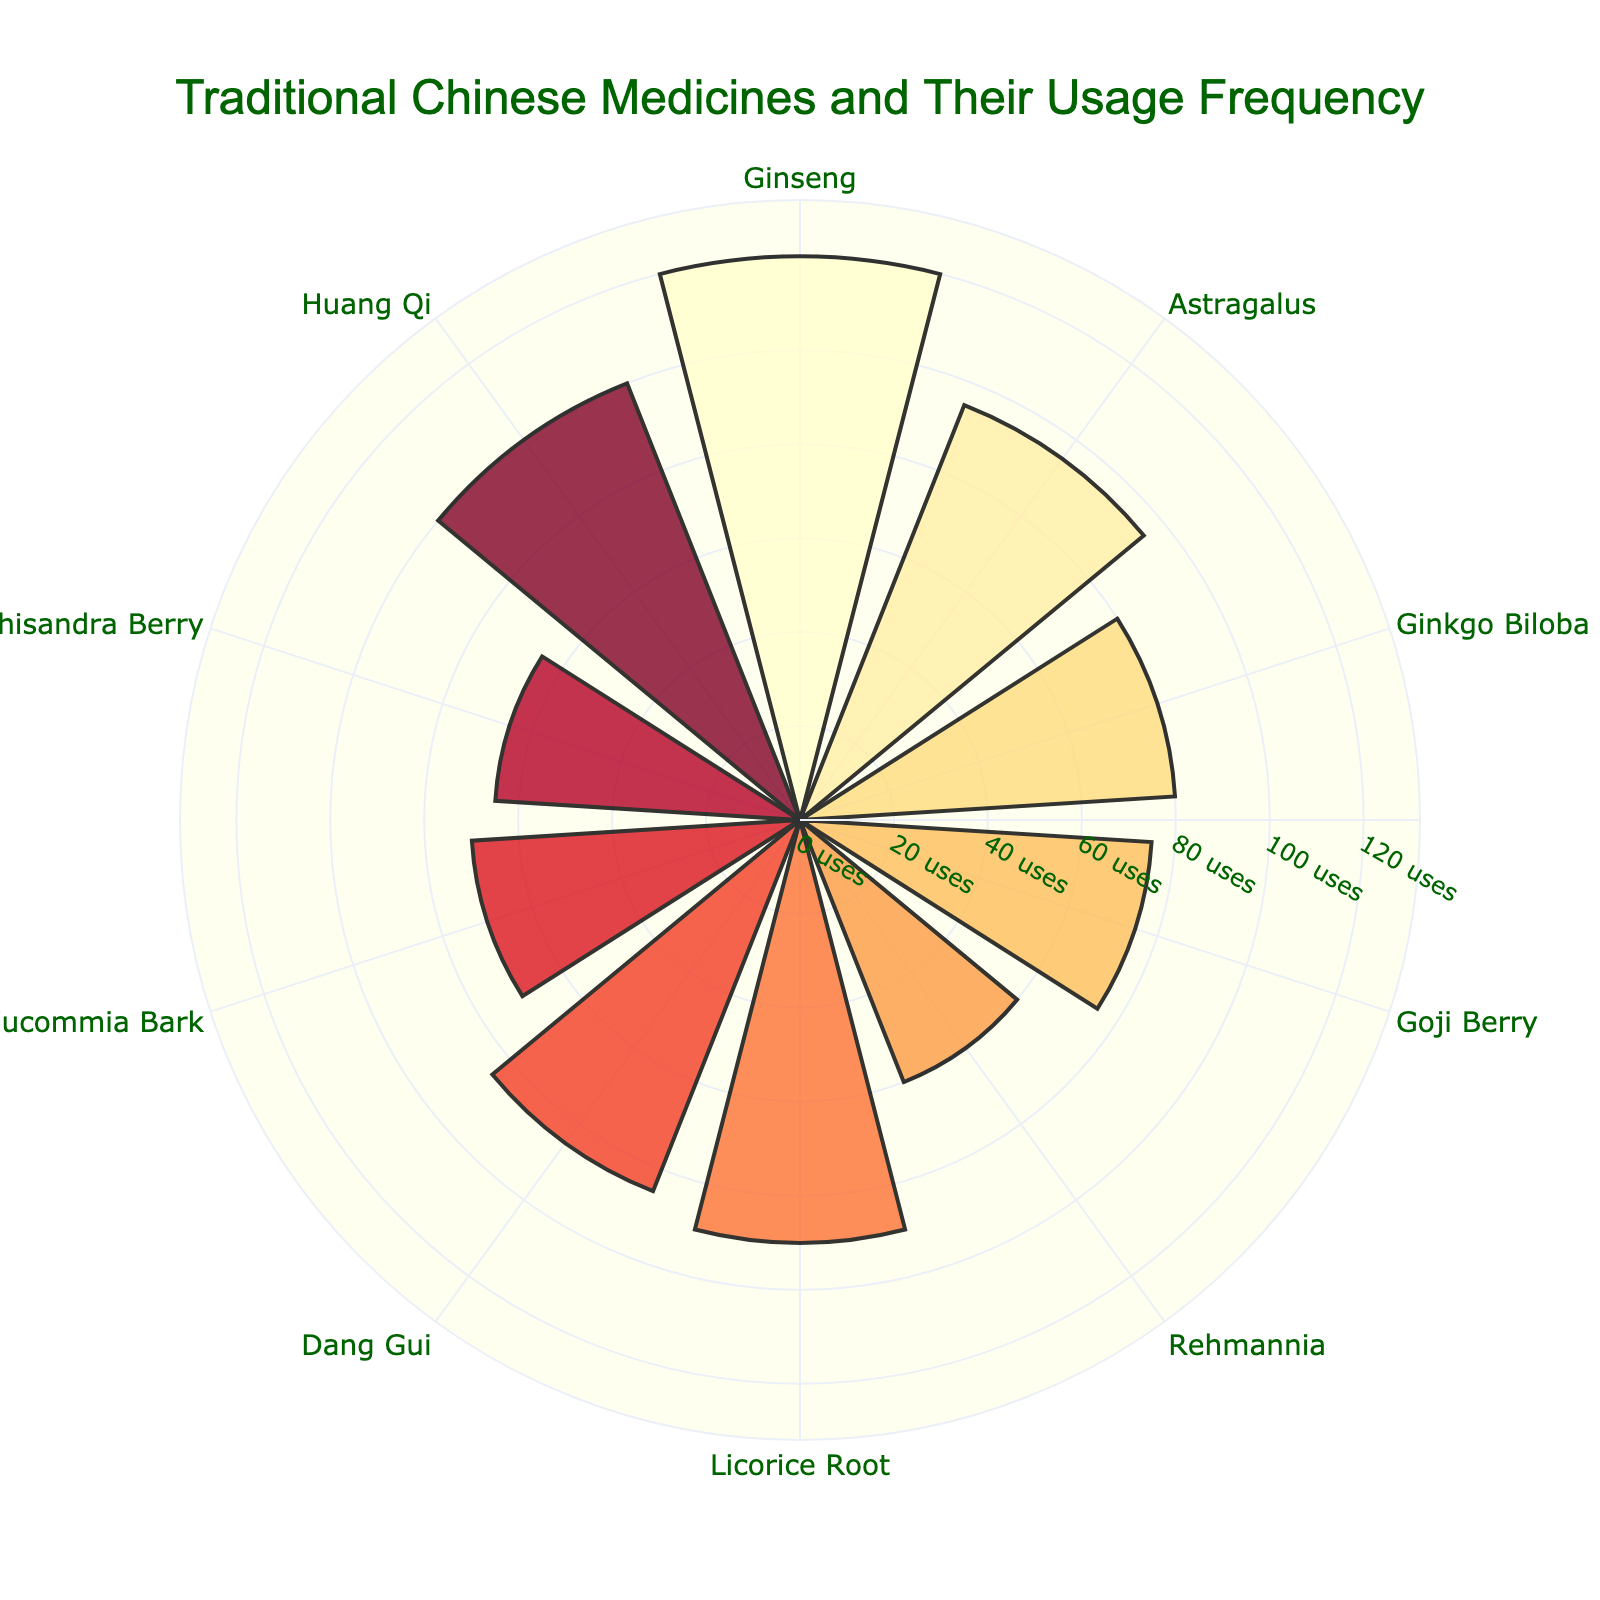What is the title of the chart? The title is located at the top of the chart and is prominently displayed in a larger font size with dark green color.
Answer: Traditional Chinese Medicines and Their Usage Frequency Which medicine has the highest usage frequency? By looking at the radial bars in the chart, the longest bar corresponds to Ginseng with the highest radial axis value.
Answer: Ginseng How many medicines have a usage frequency of 90 or more? We can count the number of bars that extend to 90 or more units on the radial axis: Ginseng, Huang Qi, Licorice Root, and Astragalus.
Answer: 4 Which medicines are used for memory enhancement and liver health? By checking the annotations added to the plot, Ginkgo Biloba is used for memory enhancement and Rehmannia is used for liver health.
Answer: Ginkgo Biloba and Rehmannia What is the difference in usage frequency between Huang Qi and Dang Gui? Huang Qi has a usage frequency of 100, and Dang Gui has 85, so the difference is 100 - 85 = 15.
Answer: 15 What is the average usage frequency of the medicines? Sum the frequencies of all the medicines and then divide by the number of medicines: (120 + 95 + 80 + 75 + 60 + 90 + 85 + 70 + 65 + 100) / 10 = 84.
Answer: 84 Which medicine is used for immune support, and how frequently is it used? According to the annotations, Astragalus is used for immune support with a usage frequency of 95.
Answer: Astragalus, 95 Which ailment has the least associated usage frequency, and what is the frequency? From the annotations, the shortest bar corresponds to Rehmannia, which is used for liver health with a usage frequency of 60.
Answer: Liver health, 60 Are there more medicines with a usage frequency above or below 80? There are five medicines with a usage frequency above 80 (Ginseng, Astragalus, Licorice Root, Dang Gui, Huang Qi) and five below 80 (Ginkgo Biloba, Goji Berry, Rehmannia, Eucommia Bark, Schisandra Berry).
Answer: Equal (5 each) Which two medicines have the closest usage frequencies and what are they? By observing the lengths of the bars, Eucommia Bark (70) and Schisandra Berry (65) have the closest values with a difference of 5.
Answer: Eucommia Bark and Schisandra Berry 